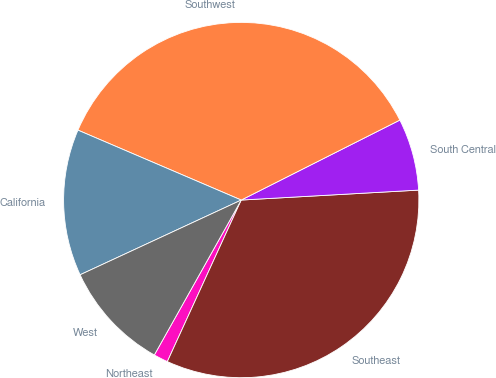Convert chart to OTSL. <chart><loc_0><loc_0><loc_500><loc_500><pie_chart><fcel>Northeast<fcel>Southeast<fcel>South Central<fcel>Southwest<fcel>California<fcel>West<nl><fcel>1.31%<fcel>32.72%<fcel>6.54%<fcel>36.13%<fcel>13.35%<fcel>9.95%<nl></chart> 